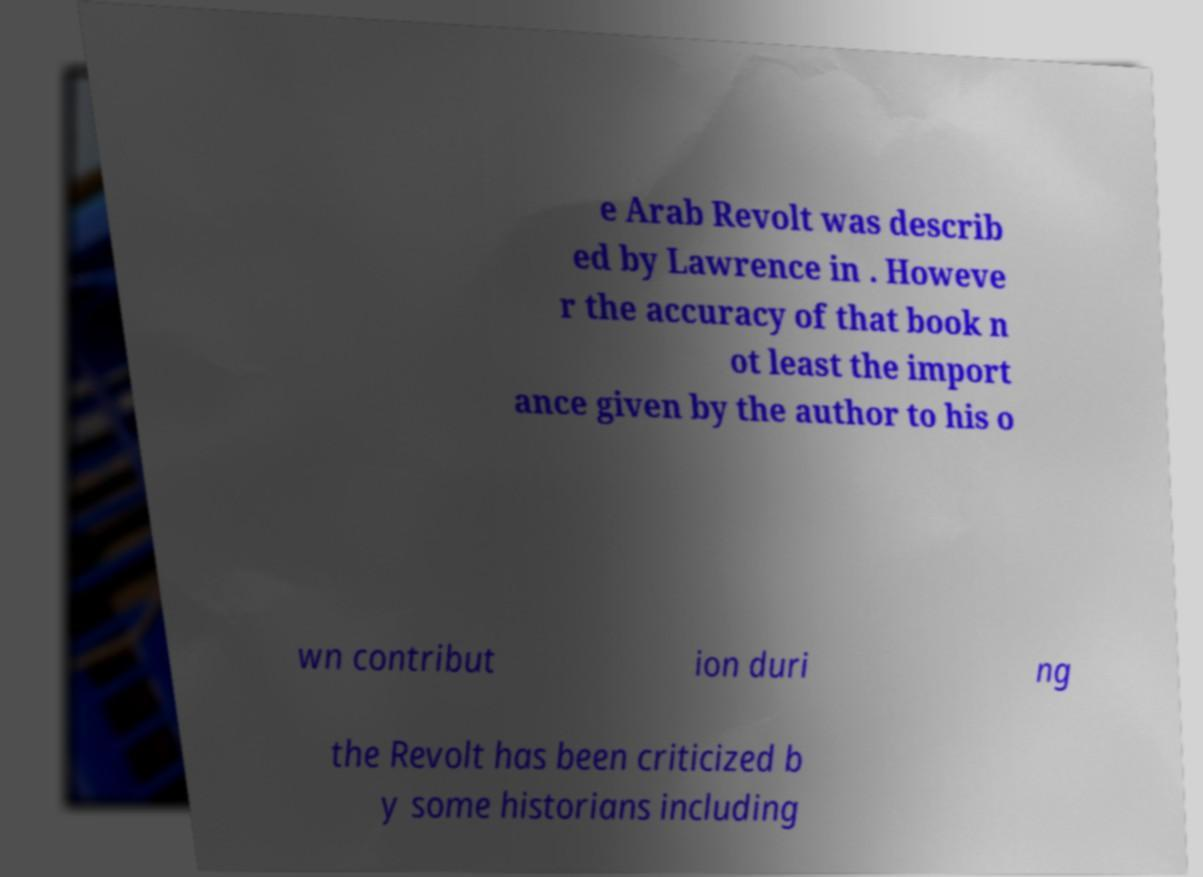Can you accurately transcribe the text from the provided image for me? e Arab Revolt was describ ed by Lawrence in . Howeve r the accuracy of that book n ot least the import ance given by the author to his o wn contribut ion duri ng the Revolt has been criticized b y some historians including 